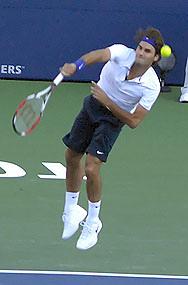Why aren't the man's feet on the ground?
Keep it brief. Jumping. Is this a man or a woman?
Answer briefly. Man. What is the color of the ball?
Be succinct. Yellow. 